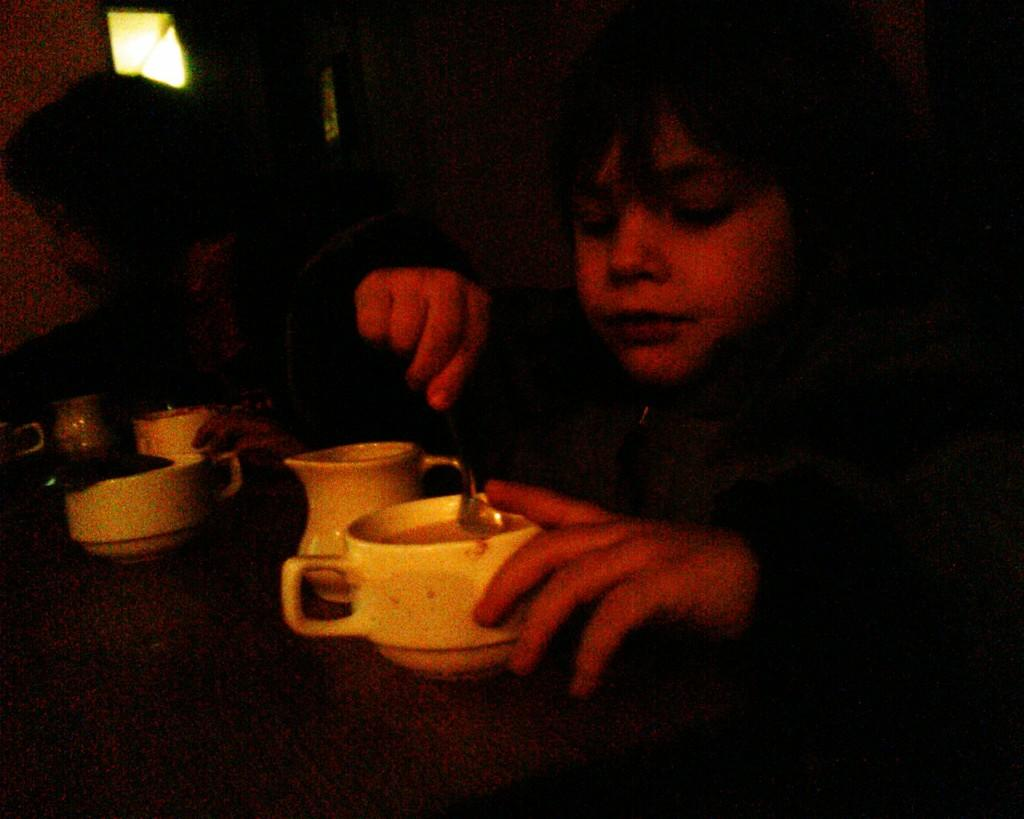What is the main subject of the image? There is a child in the image. What objects are on the table in the image? There is a cup, a spoon, and glasses on the table in the image. What type of cake is being served on the table in the image? There is no cake present in the image; only a cup, a spoon, and glasses are visible on the table. 